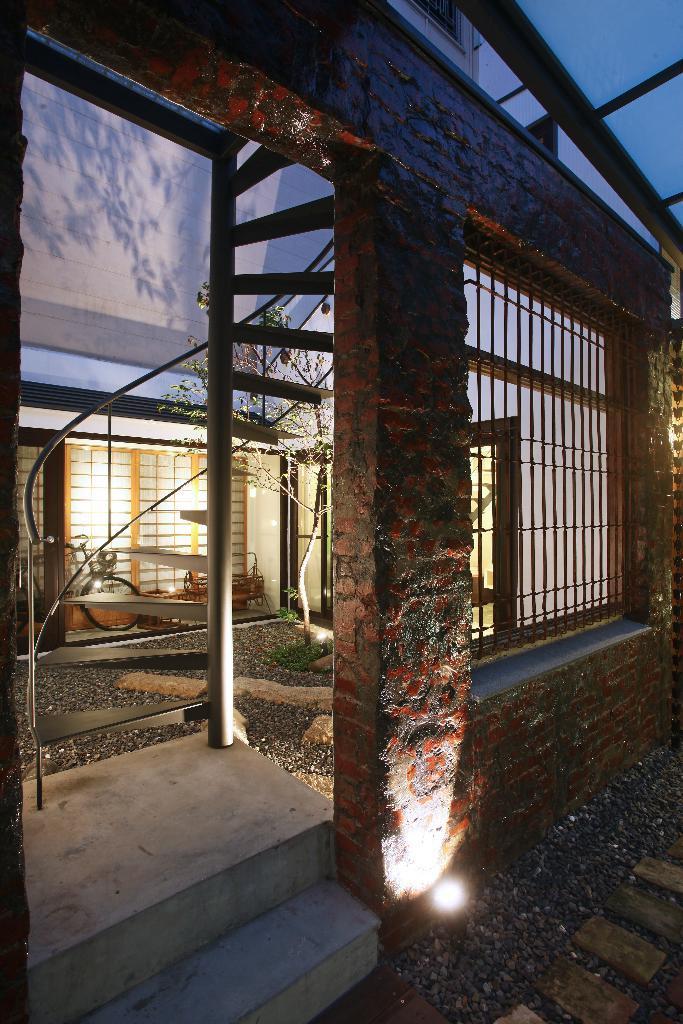Describe this image in one or two sentences. In this image we can see tree, window, bicycle, wall, pillar, steps, door and sky. 